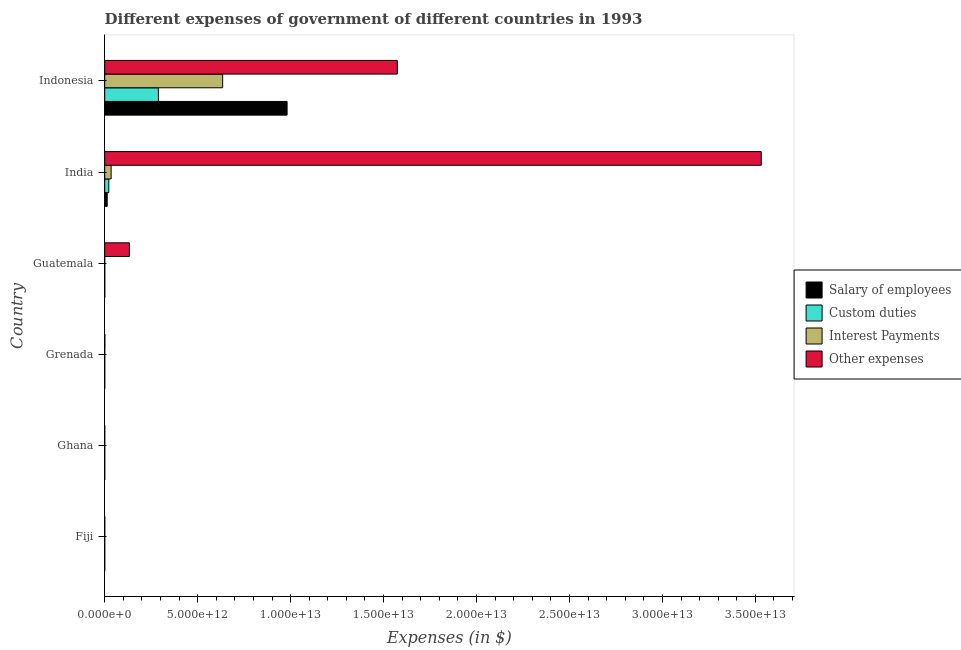How many bars are there on the 2nd tick from the top?
Keep it short and to the point. 4. What is the label of the 2nd group of bars from the top?
Give a very brief answer. India. What is the amount spent on interest payments in India?
Ensure brevity in your answer.  3.45e+11. Across all countries, what is the maximum amount spent on other expenses?
Give a very brief answer. 3.53e+13. Across all countries, what is the minimum amount spent on other expenses?
Keep it short and to the point. 1.56e+08. What is the total amount spent on salary of employees in the graph?
Your response must be concise. 9.95e+12. What is the difference between the amount spent on custom duties in Fiji and that in Guatemala?
Make the answer very short. -8.03e+08. What is the difference between the amount spent on salary of employees in Ghana and the amount spent on interest payments in India?
Your answer should be compact. -3.45e+11. What is the average amount spent on interest payments per country?
Ensure brevity in your answer.  1.11e+12. What is the difference between the amount spent on custom duties and amount spent on other expenses in Fiji?
Keep it short and to the point. -3.64e+08. Is the amount spent on interest payments in Ghana less than that in Grenada?
Ensure brevity in your answer.  Yes. Is the difference between the amount spent on other expenses in Fiji and Ghana greater than the difference between the amount spent on custom duties in Fiji and Ghana?
Ensure brevity in your answer.  Yes. What is the difference between the highest and the second highest amount spent on salary of employees?
Your response must be concise. 9.68e+12. What is the difference between the highest and the lowest amount spent on interest payments?
Make the answer very short. 6.34e+12. In how many countries, is the amount spent on other expenses greater than the average amount spent on other expenses taken over all countries?
Give a very brief answer. 2. Is the sum of the amount spent on other expenses in India and Indonesia greater than the maximum amount spent on salary of employees across all countries?
Give a very brief answer. Yes. Is it the case that in every country, the sum of the amount spent on salary of employees and amount spent on custom duties is greater than the sum of amount spent on interest payments and amount spent on other expenses?
Offer a very short reply. No. What does the 4th bar from the top in India represents?
Ensure brevity in your answer.  Salary of employees. What does the 1st bar from the bottom in Ghana represents?
Offer a terse response. Salary of employees. What is the difference between two consecutive major ticks on the X-axis?
Make the answer very short. 5.00e+12. Does the graph contain any zero values?
Provide a short and direct response. No. Does the graph contain grids?
Your answer should be very brief. No. How many legend labels are there?
Give a very brief answer. 4. How are the legend labels stacked?
Your response must be concise. Vertical. What is the title of the graph?
Your answer should be compact. Different expenses of government of different countries in 1993. What is the label or title of the X-axis?
Your answer should be very brief. Expenses (in $). What is the Expenses (in $) of Salary of employees in Fiji?
Give a very brief answer. 3.17e+08. What is the Expenses (in $) of Custom duties in Fiji?
Your response must be concise. 3.31e+08. What is the Expenses (in $) in Interest Payments in Fiji?
Your answer should be compact. 7.14e+07. What is the Expenses (in $) in Other expenses in Fiji?
Give a very brief answer. 6.96e+08. What is the Expenses (in $) of Salary of employees in Ghana?
Offer a very short reply. 2.28e+07. What is the Expenses (in $) in Custom duties in Ghana?
Your answer should be very brief. 1.33e+07. What is the Expenses (in $) of Interest Payments in Ghana?
Keep it short and to the point. 1.35e+07. What is the Expenses (in $) of Other expenses in Ghana?
Your response must be concise. 1.56e+08. What is the Expenses (in $) of Salary of employees in Grenada?
Ensure brevity in your answer.  1.02e+08. What is the Expenses (in $) of Custom duties in Grenada?
Provide a short and direct response. 3.00e+07. What is the Expenses (in $) of Interest Payments in Grenada?
Make the answer very short. 1.41e+07. What is the Expenses (in $) in Other expenses in Grenada?
Keep it short and to the point. 5.54e+09. What is the Expenses (in $) in Salary of employees in Guatemala?
Provide a succinct answer. 2.27e+09. What is the Expenses (in $) in Custom duties in Guatemala?
Your response must be concise. 1.13e+09. What is the Expenses (in $) of Interest Payments in Guatemala?
Make the answer very short. 5.79e+08. What is the Expenses (in $) in Other expenses in Guatemala?
Provide a short and direct response. 1.33e+12. What is the Expenses (in $) of Salary of employees in India?
Give a very brief answer. 1.34e+11. What is the Expenses (in $) in Custom duties in India?
Make the answer very short. 2.19e+11. What is the Expenses (in $) in Interest Payments in India?
Provide a short and direct response. 3.45e+11. What is the Expenses (in $) of Other expenses in India?
Offer a terse response. 3.53e+13. What is the Expenses (in $) in Salary of employees in Indonesia?
Ensure brevity in your answer.  9.81e+12. What is the Expenses (in $) in Custom duties in Indonesia?
Ensure brevity in your answer.  2.89e+12. What is the Expenses (in $) in Interest Payments in Indonesia?
Give a very brief answer. 6.34e+12. What is the Expenses (in $) in Other expenses in Indonesia?
Give a very brief answer. 1.57e+13. Across all countries, what is the maximum Expenses (in $) of Salary of employees?
Make the answer very short. 9.81e+12. Across all countries, what is the maximum Expenses (in $) of Custom duties?
Make the answer very short. 2.89e+12. Across all countries, what is the maximum Expenses (in $) in Interest Payments?
Provide a short and direct response. 6.34e+12. Across all countries, what is the maximum Expenses (in $) of Other expenses?
Ensure brevity in your answer.  3.53e+13. Across all countries, what is the minimum Expenses (in $) in Salary of employees?
Ensure brevity in your answer.  2.28e+07. Across all countries, what is the minimum Expenses (in $) in Custom duties?
Provide a succinct answer. 1.33e+07. Across all countries, what is the minimum Expenses (in $) of Interest Payments?
Provide a succinct answer. 1.35e+07. Across all countries, what is the minimum Expenses (in $) of Other expenses?
Offer a very short reply. 1.56e+08. What is the total Expenses (in $) of Salary of employees in the graph?
Give a very brief answer. 9.95e+12. What is the total Expenses (in $) of Custom duties in the graph?
Your response must be concise. 3.11e+12. What is the total Expenses (in $) of Interest Payments in the graph?
Make the answer very short. 6.69e+12. What is the total Expenses (in $) of Other expenses in the graph?
Provide a succinct answer. 5.24e+13. What is the difference between the Expenses (in $) of Salary of employees in Fiji and that in Ghana?
Your answer should be very brief. 2.94e+08. What is the difference between the Expenses (in $) in Custom duties in Fiji and that in Ghana?
Your answer should be compact. 3.18e+08. What is the difference between the Expenses (in $) of Interest Payments in Fiji and that in Ghana?
Make the answer very short. 5.79e+07. What is the difference between the Expenses (in $) of Other expenses in Fiji and that in Ghana?
Give a very brief answer. 5.40e+08. What is the difference between the Expenses (in $) of Salary of employees in Fiji and that in Grenada?
Offer a terse response. 2.15e+08. What is the difference between the Expenses (in $) in Custom duties in Fiji and that in Grenada?
Offer a terse response. 3.01e+08. What is the difference between the Expenses (in $) of Interest Payments in Fiji and that in Grenada?
Your response must be concise. 5.72e+07. What is the difference between the Expenses (in $) of Other expenses in Fiji and that in Grenada?
Your answer should be compact. -4.85e+09. What is the difference between the Expenses (in $) of Salary of employees in Fiji and that in Guatemala?
Offer a very short reply. -1.95e+09. What is the difference between the Expenses (in $) of Custom duties in Fiji and that in Guatemala?
Ensure brevity in your answer.  -8.03e+08. What is the difference between the Expenses (in $) in Interest Payments in Fiji and that in Guatemala?
Your answer should be very brief. -5.07e+08. What is the difference between the Expenses (in $) of Other expenses in Fiji and that in Guatemala?
Offer a terse response. -1.33e+12. What is the difference between the Expenses (in $) of Salary of employees in Fiji and that in India?
Your response must be concise. -1.33e+11. What is the difference between the Expenses (in $) of Custom duties in Fiji and that in India?
Offer a terse response. -2.19e+11. What is the difference between the Expenses (in $) in Interest Payments in Fiji and that in India?
Your response must be concise. -3.45e+11. What is the difference between the Expenses (in $) in Other expenses in Fiji and that in India?
Provide a succinct answer. -3.53e+13. What is the difference between the Expenses (in $) in Salary of employees in Fiji and that in Indonesia?
Ensure brevity in your answer.  -9.81e+12. What is the difference between the Expenses (in $) of Custom duties in Fiji and that in Indonesia?
Your answer should be very brief. -2.89e+12. What is the difference between the Expenses (in $) of Interest Payments in Fiji and that in Indonesia?
Provide a succinct answer. -6.34e+12. What is the difference between the Expenses (in $) in Other expenses in Fiji and that in Indonesia?
Your answer should be very brief. -1.57e+13. What is the difference between the Expenses (in $) of Salary of employees in Ghana and that in Grenada?
Provide a succinct answer. -7.96e+07. What is the difference between the Expenses (in $) of Custom duties in Ghana and that in Grenada?
Offer a terse response. -1.67e+07. What is the difference between the Expenses (in $) of Interest Payments in Ghana and that in Grenada?
Your response must be concise. -6.22e+05. What is the difference between the Expenses (in $) of Other expenses in Ghana and that in Grenada?
Ensure brevity in your answer.  -5.39e+09. What is the difference between the Expenses (in $) in Salary of employees in Ghana and that in Guatemala?
Provide a succinct answer. -2.25e+09. What is the difference between the Expenses (in $) of Custom duties in Ghana and that in Guatemala?
Ensure brevity in your answer.  -1.12e+09. What is the difference between the Expenses (in $) of Interest Payments in Ghana and that in Guatemala?
Provide a succinct answer. -5.65e+08. What is the difference between the Expenses (in $) of Other expenses in Ghana and that in Guatemala?
Give a very brief answer. -1.33e+12. What is the difference between the Expenses (in $) in Salary of employees in Ghana and that in India?
Offer a very short reply. -1.34e+11. What is the difference between the Expenses (in $) in Custom duties in Ghana and that in India?
Give a very brief answer. -2.19e+11. What is the difference between the Expenses (in $) of Interest Payments in Ghana and that in India?
Offer a very short reply. -3.45e+11. What is the difference between the Expenses (in $) of Other expenses in Ghana and that in India?
Ensure brevity in your answer.  -3.53e+13. What is the difference between the Expenses (in $) in Salary of employees in Ghana and that in Indonesia?
Make the answer very short. -9.81e+12. What is the difference between the Expenses (in $) in Custom duties in Ghana and that in Indonesia?
Offer a terse response. -2.89e+12. What is the difference between the Expenses (in $) in Interest Payments in Ghana and that in Indonesia?
Keep it short and to the point. -6.34e+12. What is the difference between the Expenses (in $) of Other expenses in Ghana and that in Indonesia?
Offer a terse response. -1.57e+13. What is the difference between the Expenses (in $) in Salary of employees in Grenada and that in Guatemala?
Make the answer very short. -2.17e+09. What is the difference between the Expenses (in $) of Custom duties in Grenada and that in Guatemala?
Provide a short and direct response. -1.10e+09. What is the difference between the Expenses (in $) of Interest Payments in Grenada and that in Guatemala?
Your answer should be very brief. -5.65e+08. What is the difference between the Expenses (in $) in Other expenses in Grenada and that in Guatemala?
Provide a succinct answer. -1.32e+12. What is the difference between the Expenses (in $) of Salary of employees in Grenada and that in India?
Ensure brevity in your answer.  -1.33e+11. What is the difference between the Expenses (in $) in Custom duties in Grenada and that in India?
Keep it short and to the point. -2.19e+11. What is the difference between the Expenses (in $) of Interest Payments in Grenada and that in India?
Make the answer very short. -3.45e+11. What is the difference between the Expenses (in $) in Other expenses in Grenada and that in India?
Your response must be concise. -3.53e+13. What is the difference between the Expenses (in $) of Salary of employees in Grenada and that in Indonesia?
Make the answer very short. -9.81e+12. What is the difference between the Expenses (in $) of Custom duties in Grenada and that in Indonesia?
Ensure brevity in your answer.  -2.89e+12. What is the difference between the Expenses (in $) of Interest Payments in Grenada and that in Indonesia?
Ensure brevity in your answer.  -6.34e+12. What is the difference between the Expenses (in $) in Other expenses in Grenada and that in Indonesia?
Your answer should be compact. -1.57e+13. What is the difference between the Expenses (in $) of Salary of employees in Guatemala and that in India?
Your answer should be compact. -1.31e+11. What is the difference between the Expenses (in $) in Custom duties in Guatemala and that in India?
Your answer should be very brief. -2.18e+11. What is the difference between the Expenses (in $) in Interest Payments in Guatemala and that in India?
Keep it short and to the point. -3.44e+11. What is the difference between the Expenses (in $) in Other expenses in Guatemala and that in India?
Make the answer very short. -3.40e+13. What is the difference between the Expenses (in $) of Salary of employees in Guatemala and that in Indonesia?
Provide a short and direct response. -9.81e+12. What is the difference between the Expenses (in $) in Custom duties in Guatemala and that in Indonesia?
Offer a terse response. -2.89e+12. What is the difference between the Expenses (in $) of Interest Payments in Guatemala and that in Indonesia?
Your answer should be compact. -6.34e+12. What is the difference between the Expenses (in $) of Other expenses in Guatemala and that in Indonesia?
Your response must be concise. -1.44e+13. What is the difference between the Expenses (in $) of Salary of employees in India and that in Indonesia?
Your response must be concise. -9.68e+12. What is the difference between the Expenses (in $) in Custom duties in India and that in Indonesia?
Give a very brief answer. -2.67e+12. What is the difference between the Expenses (in $) in Interest Payments in India and that in Indonesia?
Your answer should be very brief. -6.00e+12. What is the difference between the Expenses (in $) in Other expenses in India and that in Indonesia?
Offer a very short reply. 1.96e+13. What is the difference between the Expenses (in $) in Salary of employees in Fiji and the Expenses (in $) in Custom duties in Ghana?
Give a very brief answer. 3.04e+08. What is the difference between the Expenses (in $) of Salary of employees in Fiji and the Expenses (in $) of Interest Payments in Ghana?
Your response must be concise. 3.04e+08. What is the difference between the Expenses (in $) of Salary of employees in Fiji and the Expenses (in $) of Other expenses in Ghana?
Provide a succinct answer. 1.62e+08. What is the difference between the Expenses (in $) of Custom duties in Fiji and the Expenses (in $) of Interest Payments in Ghana?
Make the answer very short. 3.18e+08. What is the difference between the Expenses (in $) in Custom duties in Fiji and the Expenses (in $) in Other expenses in Ghana?
Offer a very short reply. 1.76e+08. What is the difference between the Expenses (in $) of Interest Payments in Fiji and the Expenses (in $) of Other expenses in Ghana?
Your answer should be compact. -8.42e+07. What is the difference between the Expenses (in $) in Salary of employees in Fiji and the Expenses (in $) in Custom duties in Grenada?
Your answer should be very brief. 2.87e+08. What is the difference between the Expenses (in $) of Salary of employees in Fiji and the Expenses (in $) of Interest Payments in Grenada?
Your answer should be very brief. 3.03e+08. What is the difference between the Expenses (in $) in Salary of employees in Fiji and the Expenses (in $) in Other expenses in Grenada?
Make the answer very short. -5.22e+09. What is the difference between the Expenses (in $) in Custom duties in Fiji and the Expenses (in $) in Interest Payments in Grenada?
Offer a very short reply. 3.17e+08. What is the difference between the Expenses (in $) in Custom duties in Fiji and the Expenses (in $) in Other expenses in Grenada?
Your answer should be compact. -5.21e+09. What is the difference between the Expenses (in $) in Interest Payments in Fiji and the Expenses (in $) in Other expenses in Grenada?
Offer a very short reply. -5.47e+09. What is the difference between the Expenses (in $) of Salary of employees in Fiji and the Expenses (in $) of Custom duties in Guatemala?
Provide a short and direct response. -8.17e+08. What is the difference between the Expenses (in $) of Salary of employees in Fiji and the Expenses (in $) of Interest Payments in Guatemala?
Offer a terse response. -2.62e+08. What is the difference between the Expenses (in $) in Salary of employees in Fiji and the Expenses (in $) in Other expenses in Guatemala?
Keep it short and to the point. -1.33e+12. What is the difference between the Expenses (in $) in Custom duties in Fiji and the Expenses (in $) in Interest Payments in Guatemala?
Make the answer very short. -2.47e+08. What is the difference between the Expenses (in $) of Custom duties in Fiji and the Expenses (in $) of Other expenses in Guatemala?
Provide a succinct answer. -1.33e+12. What is the difference between the Expenses (in $) in Interest Payments in Fiji and the Expenses (in $) in Other expenses in Guatemala?
Make the answer very short. -1.33e+12. What is the difference between the Expenses (in $) of Salary of employees in Fiji and the Expenses (in $) of Custom duties in India?
Make the answer very short. -2.19e+11. What is the difference between the Expenses (in $) of Salary of employees in Fiji and the Expenses (in $) of Interest Payments in India?
Your answer should be compact. -3.45e+11. What is the difference between the Expenses (in $) of Salary of employees in Fiji and the Expenses (in $) of Other expenses in India?
Make the answer very short. -3.53e+13. What is the difference between the Expenses (in $) in Custom duties in Fiji and the Expenses (in $) in Interest Payments in India?
Your response must be concise. -3.45e+11. What is the difference between the Expenses (in $) in Custom duties in Fiji and the Expenses (in $) in Other expenses in India?
Ensure brevity in your answer.  -3.53e+13. What is the difference between the Expenses (in $) of Interest Payments in Fiji and the Expenses (in $) of Other expenses in India?
Give a very brief answer. -3.53e+13. What is the difference between the Expenses (in $) of Salary of employees in Fiji and the Expenses (in $) of Custom duties in Indonesia?
Give a very brief answer. -2.89e+12. What is the difference between the Expenses (in $) of Salary of employees in Fiji and the Expenses (in $) of Interest Payments in Indonesia?
Provide a short and direct response. -6.34e+12. What is the difference between the Expenses (in $) of Salary of employees in Fiji and the Expenses (in $) of Other expenses in Indonesia?
Provide a short and direct response. -1.57e+13. What is the difference between the Expenses (in $) of Custom duties in Fiji and the Expenses (in $) of Interest Payments in Indonesia?
Your answer should be very brief. -6.34e+12. What is the difference between the Expenses (in $) in Custom duties in Fiji and the Expenses (in $) in Other expenses in Indonesia?
Offer a terse response. -1.57e+13. What is the difference between the Expenses (in $) in Interest Payments in Fiji and the Expenses (in $) in Other expenses in Indonesia?
Provide a succinct answer. -1.57e+13. What is the difference between the Expenses (in $) of Salary of employees in Ghana and the Expenses (in $) of Custom duties in Grenada?
Your answer should be very brief. -7.21e+06. What is the difference between the Expenses (in $) in Salary of employees in Ghana and the Expenses (in $) in Interest Payments in Grenada?
Your answer should be compact. 8.66e+06. What is the difference between the Expenses (in $) in Salary of employees in Ghana and the Expenses (in $) in Other expenses in Grenada?
Your answer should be very brief. -5.52e+09. What is the difference between the Expenses (in $) of Custom duties in Ghana and the Expenses (in $) of Interest Payments in Grenada?
Your answer should be compact. -8.35e+05. What is the difference between the Expenses (in $) in Custom duties in Ghana and the Expenses (in $) in Other expenses in Grenada?
Your response must be concise. -5.53e+09. What is the difference between the Expenses (in $) of Interest Payments in Ghana and the Expenses (in $) of Other expenses in Grenada?
Keep it short and to the point. -5.53e+09. What is the difference between the Expenses (in $) of Salary of employees in Ghana and the Expenses (in $) of Custom duties in Guatemala?
Your response must be concise. -1.11e+09. What is the difference between the Expenses (in $) in Salary of employees in Ghana and the Expenses (in $) in Interest Payments in Guatemala?
Your answer should be very brief. -5.56e+08. What is the difference between the Expenses (in $) of Salary of employees in Ghana and the Expenses (in $) of Other expenses in Guatemala?
Your answer should be very brief. -1.33e+12. What is the difference between the Expenses (in $) of Custom duties in Ghana and the Expenses (in $) of Interest Payments in Guatemala?
Give a very brief answer. -5.66e+08. What is the difference between the Expenses (in $) in Custom duties in Ghana and the Expenses (in $) in Other expenses in Guatemala?
Provide a succinct answer. -1.33e+12. What is the difference between the Expenses (in $) in Interest Payments in Ghana and the Expenses (in $) in Other expenses in Guatemala?
Ensure brevity in your answer.  -1.33e+12. What is the difference between the Expenses (in $) in Salary of employees in Ghana and the Expenses (in $) in Custom duties in India?
Your response must be concise. -2.19e+11. What is the difference between the Expenses (in $) of Salary of employees in Ghana and the Expenses (in $) of Interest Payments in India?
Your answer should be compact. -3.45e+11. What is the difference between the Expenses (in $) of Salary of employees in Ghana and the Expenses (in $) of Other expenses in India?
Offer a terse response. -3.53e+13. What is the difference between the Expenses (in $) of Custom duties in Ghana and the Expenses (in $) of Interest Payments in India?
Your answer should be very brief. -3.45e+11. What is the difference between the Expenses (in $) in Custom duties in Ghana and the Expenses (in $) in Other expenses in India?
Give a very brief answer. -3.53e+13. What is the difference between the Expenses (in $) in Interest Payments in Ghana and the Expenses (in $) in Other expenses in India?
Your response must be concise. -3.53e+13. What is the difference between the Expenses (in $) of Salary of employees in Ghana and the Expenses (in $) of Custom duties in Indonesia?
Keep it short and to the point. -2.89e+12. What is the difference between the Expenses (in $) of Salary of employees in Ghana and the Expenses (in $) of Interest Payments in Indonesia?
Make the answer very short. -6.34e+12. What is the difference between the Expenses (in $) in Salary of employees in Ghana and the Expenses (in $) in Other expenses in Indonesia?
Give a very brief answer. -1.57e+13. What is the difference between the Expenses (in $) of Custom duties in Ghana and the Expenses (in $) of Interest Payments in Indonesia?
Provide a succinct answer. -6.34e+12. What is the difference between the Expenses (in $) of Custom duties in Ghana and the Expenses (in $) of Other expenses in Indonesia?
Provide a short and direct response. -1.57e+13. What is the difference between the Expenses (in $) in Interest Payments in Ghana and the Expenses (in $) in Other expenses in Indonesia?
Ensure brevity in your answer.  -1.57e+13. What is the difference between the Expenses (in $) of Salary of employees in Grenada and the Expenses (in $) of Custom duties in Guatemala?
Ensure brevity in your answer.  -1.03e+09. What is the difference between the Expenses (in $) in Salary of employees in Grenada and the Expenses (in $) in Interest Payments in Guatemala?
Offer a very short reply. -4.76e+08. What is the difference between the Expenses (in $) of Salary of employees in Grenada and the Expenses (in $) of Other expenses in Guatemala?
Provide a succinct answer. -1.33e+12. What is the difference between the Expenses (in $) of Custom duties in Grenada and the Expenses (in $) of Interest Payments in Guatemala?
Your response must be concise. -5.49e+08. What is the difference between the Expenses (in $) in Custom duties in Grenada and the Expenses (in $) in Other expenses in Guatemala?
Your answer should be compact. -1.33e+12. What is the difference between the Expenses (in $) of Interest Payments in Grenada and the Expenses (in $) of Other expenses in Guatemala?
Offer a very short reply. -1.33e+12. What is the difference between the Expenses (in $) in Salary of employees in Grenada and the Expenses (in $) in Custom duties in India?
Offer a very short reply. -2.19e+11. What is the difference between the Expenses (in $) in Salary of employees in Grenada and the Expenses (in $) in Interest Payments in India?
Give a very brief answer. -3.45e+11. What is the difference between the Expenses (in $) in Salary of employees in Grenada and the Expenses (in $) in Other expenses in India?
Your answer should be compact. -3.53e+13. What is the difference between the Expenses (in $) of Custom duties in Grenada and the Expenses (in $) of Interest Payments in India?
Provide a short and direct response. -3.45e+11. What is the difference between the Expenses (in $) in Custom duties in Grenada and the Expenses (in $) in Other expenses in India?
Offer a very short reply. -3.53e+13. What is the difference between the Expenses (in $) in Interest Payments in Grenada and the Expenses (in $) in Other expenses in India?
Provide a short and direct response. -3.53e+13. What is the difference between the Expenses (in $) in Salary of employees in Grenada and the Expenses (in $) in Custom duties in Indonesia?
Ensure brevity in your answer.  -2.89e+12. What is the difference between the Expenses (in $) in Salary of employees in Grenada and the Expenses (in $) in Interest Payments in Indonesia?
Ensure brevity in your answer.  -6.34e+12. What is the difference between the Expenses (in $) of Salary of employees in Grenada and the Expenses (in $) of Other expenses in Indonesia?
Offer a terse response. -1.57e+13. What is the difference between the Expenses (in $) in Custom duties in Grenada and the Expenses (in $) in Interest Payments in Indonesia?
Provide a succinct answer. -6.34e+12. What is the difference between the Expenses (in $) in Custom duties in Grenada and the Expenses (in $) in Other expenses in Indonesia?
Offer a terse response. -1.57e+13. What is the difference between the Expenses (in $) in Interest Payments in Grenada and the Expenses (in $) in Other expenses in Indonesia?
Provide a succinct answer. -1.57e+13. What is the difference between the Expenses (in $) of Salary of employees in Guatemala and the Expenses (in $) of Custom duties in India?
Your answer should be very brief. -2.17e+11. What is the difference between the Expenses (in $) in Salary of employees in Guatemala and the Expenses (in $) in Interest Payments in India?
Your response must be concise. -3.43e+11. What is the difference between the Expenses (in $) in Salary of employees in Guatemala and the Expenses (in $) in Other expenses in India?
Your response must be concise. -3.53e+13. What is the difference between the Expenses (in $) of Custom duties in Guatemala and the Expenses (in $) of Interest Payments in India?
Your answer should be compact. -3.44e+11. What is the difference between the Expenses (in $) in Custom duties in Guatemala and the Expenses (in $) in Other expenses in India?
Your response must be concise. -3.53e+13. What is the difference between the Expenses (in $) of Interest Payments in Guatemala and the Expenses (in $) of Other expenses in India?
Give a very brief answer. -3.53e+13. What is the difference between the Expenses (in $) of Salary of employees in Guatemala and the Expenses (in $) of Custom duties in Indonesia?
Keep it short and to the point. -2.89e+12. What is the difference between the Expenses (in $) in Salary of employees in Guatemala and the Expenses (in $) in Interest Payments in Indonesia?
Your answer should be compact. -6.34e+12. What is the difference between the Expenses (in $) in Salary of employees in Guatemala and the Expenses (in $) in Other expenses in Indonesia?
Offer a terse response. -1.57e+13. What is the difference between the Expenses (in $) of Custom duties in Guatemala and the Expenses (in $) of Interest Payments in Indonesia?
Provide a short and direct response. -6.34e+12. What is the difference between the Expenses (in $) of Custom duties in Guatemala and the Expenses (in $) of Other expenses in Indonesia?
Your answer should be compact. -1.57e+13. What is the difference between the Expenses (in $) of Interest Payments in Guatemala and the Expenses (in $) of Other expenses in Indonesia?
Your response must be concise. -1.57e+13. What is the difference between the Expenses (in $) of Salary of employees in India and the Expenses (in $) of Custom duties in Indonesia?
Give a very brief answer. -2.75e+12. What is the difference between the Expenses (in $) of Salary of employees in India and the Expenses (in $) of Interest Payments in Indonesia?
Your answer should be compact. -6.21e+12. What is the difference between the Expenses (in $) of Salary of employees in India and the Expenses (in $) of Other expenses in Indonesia?
Your answer should be very brief. -1.56e+13. What is the difference between the Expenses (in $) of Custom duties in India and the Expenses (in $) of Interest Payments in Indonesia?
Offer a terse response. -6.12e+12. What is the difference between the Expenses (in $) in Custom duties in India and the Expenses (in $) in Other expenses in Indonesia?
Keep it short and to the point. -1.55e+13. What is the difference between the Expenses (in $) in Interest Payments in India and the Expenses (in $) in Other expenses in Indonesia?
Your answer should be very brief. -1.54e+13. What is the average Expenses (in $) in Salary of employees per country?
Provide a succinct answer. 1.66e+12. What is the average Expenses (in $) in Custom duties per country?
Give a very brief answer. 5.18e+11. What is the average Expenses (in $) in Interest Payments per country?
Provide a short and direct response. 1.11e+12. What is the average Expenses (in $) of Other expenses per country?
Provide a short and direct response. 8.73e+12. What is the difference between the Expenses (in $) in Salary of employees and Expenses (in $) in Custom duties in Fiji?
Your answer should be very brief. -1.42e+07. What is the difference between the Expenses (in $) in Salary of employees and Expenses (in $) in Interest Payments in Fiji?
Ensure brevity in your answer.  2.46e+08. What is the difference between the Expenses (in $) of Salary of employees and Expenses (in $) of Other expenses in Fiji?
Your response must be concise. -3.78e+08. What is the difference between the Expenses (in $) in Custom duties and Expenses (in $) in Interest Payments in Fiji?
Your answer should be very brief. 2.60e+08. What is the difference between the Expenses (in $) in Custom duties and Expenses (in $) in Other expenses in Fiji?
Make the answer very short. -3.64e+08. What is the difference between the Expenses (in $) in Interest Payments and Expenses (in $) in Other expenses in Fiji?
Offer a very short reply. -6.24e+08. What is the difference between the Expenses (in $) of Salary of employees and Expenses (in $) of Custom duties in Ghana?
Keep it short and to the point. 9.49e+06. What is the difference between the Expenses (in $) in Salary of employees and Expenses (in $) in Interest Payments in Ghana?
Provide a succinct answer. 9.28e+06. What is the difference between the Expenses (in $) of Salary of employees and Expenses (in $) of Other expenses in Ghana?
Your response must be concise. -1.33e+08. What is the difference between the Expenses (in $) in Custom duties and Expenses (in $) in Interest Payments in Ghana?
Provide a succinct answer. -2.12e+05. What is the difference between the Expenses (in $) of Custom duties and Expenses (in $) of Other expenses in Ghana?
Your answer should be very brief. -1.42e+08. What is the difference between the Expenses (in $) in Interest Payments and Expenses (in $) in Other expenses in Ghana?
Ensure brevity in your answer.  -1.42e+08. What is the difference between the Expenses (in $) in Salary of employees and Expenses (in $) in Custom duties in Grenada?
Offer a very short reply. 7.24e+07. What is the difference between the Expenses (in $) in Salary of employees and Expenses (in $) in Interest Payments in Grenada?
Make the answer very short. 8.82e+07. What is the difference between the Expenses (in $) in Salary of employees and Expenses (in $) in Other expenses in Grenada?
Your response must be concise. -5.44e+09. What is the difference between the Expenses (in $) of Custom duties and Expenses (in $) of Interest Payments in Grenada?
Provide a short and direct response. 1.59e+07. What is the difference between the Expenses (in $) of Custom duties and Expenses (in $) of Other expenses in Grenada?
Your answer should be very brief. -5.51e+09. What is the difference between the Expenses (in $) of Interest Payments and Expenses (in $) of Other expenses in Grenada?
Offer a very short reply. -5.53e+09. What is the difference between the Expenses (in $) in Salary of employees and Expenses (in $) in Custom duties in Guatemala?
Offer a very short reply. 1.14e+09. What is the difference between the Expenses (in $) of Salary of employees and Expenses (in $) of Interest Payments in Guatemala?
Ensure brevity in your answer.  1.69e+09. What is the difference between the Expenses (in $) of Salary of employees and Expenses (in $) of Other expenses in Guatemala?
Make the answer very short. -1.32e+12. What is the difference between the Expenses (in $) of Custom duties and Expenses (in $) of Interest Payments in Guatemala?
Keep it short and to the point. 5.55e+08. What is the difference between the Expenses (in $) of Custom duties and Expenses (in $) of Other expenses in Guatemala?
Offer a very short reply. -1.33e+12. What is the difference between the Expenses (in $) of Interest Payments and Expenses (in $) of Other expenses in Guatemala?
Your response must be concise. -1.33e+12. What is the difference between the Expenses (in $) in Salary of employees and Expenses (in $) in Custom duties in India?
Offer a terse response. -8.55e+1. What is the difference between the Expenses (in $) in Salary of employees and Expenses (in $) in Interest Payments in India?
Your answer should be compact. -2.11e+11. What is the difference between the Expenses (in $) in Salary of employees and Expenses (in $) in Other expenses in India?
Your answer should be compact. -3.52e+13. What is the difference between the Expenses (in $) of Custom duties and Expenses (in $) of Interest Payments in India?
Offer a very short reply. -1.26e+11. What is the difference between the Expenses (in $) of Custom duties and Expenses (in $) of Other expenses in India?
Your response must be concise. -3.51e+13. What is the difference between the Expenses (in $) of Interest Payments and Expenses (in $) of Other expenses in India?
Make the answer very short. -3.50e+13. What is the difference between the Expenses (in $) of Salary of employees and Expenses (in $) of Custom duties in Indonesia?
Your answer should be compact. 6.92e+12. What is the difference between the Expenses (in $) in Salary of employees and Expenses (in $) in Interest Payments in Indonesia?
Offer a very short reply. 3.47e+12. What is the difference between the Expenses (in $) of Salary of employees and Expenses (in $) of Other expenses in Indonesia?
Your response must be concise. -5.93e+12. What is the difference between the Expenses (in $) of Custom duties and Expenses (in $) of Interest Payments in Indonesia?
Provide a succinct answer. -3.46e+12. What is the difference between the Expenses (in $) of Custom duties and Expenses (in $) of Other expenses in Indonesia?
Give a very brief answer. -1.29e+13. What is the difference between the Expenses (in $) in Interest Payments and Expenses (in $) in Other expenses in Indonesia?
Provide a succinct answer. -9.40e+12. What is the ratio of the Expenses (in $) in Salary of employees in Fiji to that in Ghana?
Provide a succinct answer. 13.94. What is the ratio of the Expenses (in $) of Custom duties in Fiji to that in Ghana?
Provide a short and direct response. 24.98. What is the ratio of the Expenses (in $) in Interest Payments in Fiji to that in Ghana?
Offer a very short reply. 5.29. What is the ratio of the Expenses (in $) in Other expenses in Fiji to that in Ghana?
Your answer should be compact. 4.47. What is the ratio of the Expenses (in $) of Salary of employees in Fiji to that in Grenada?
Your answer should be very brief. 3.1. What is the ratio of the Expenses (in $) in Custom duties in Fiji to that in Grenada?
Offer a very short reply. 11.06. What is the ratio of the Expenses (in $) of Interest Payments in Fiji to that in Grenada?
Give a very brief answer. 5.06. What is the ratio of the Expenses (in $) in Other expenses in Fiji to that in Grenada?
Offer a very short reply. 0.13. What is the ratio of the Expenses (in $) in Salary of employees in Fiji to that in Guatemala?
Offer a terse response. 0.14. What is the ratio of the Expenses (in $) in Custom duties in Fiji to that in Guatemala?
Your answer should be compact. 0.29. What is the ratio of the Expenses (in $) of Interest Payments in Fiji to that in Guatemala?
Give a very brief answer. 0.12. What is the ratio of the Expenses (in $) in Other expenses in Fiji to that in Guatemala?
Your answer should be compact. 0. What is the ratio of the Expenses (in $) of Salary of employees in Fiji to that in India?
Make the answer very short. 0. What is the ratio of the Expenses (in $) in Custom duties in Fiji to that in India?
Your response must be concise. 0. What is the ratio of the Expenses (in $) in Salary of employees in Fiji to that in Indonesia?
Your response must be concise. 0. What is the ratio of the Expenses (in $) of Salary of employees in Ghana to that in Grenada?
Your response must be concise. 0.22. What is the ratio of the Expenses (in $) in Custom duties in Ghana to that in Grenada?
Keep it short and to the point. 0.44. What is the ratio of the Expenses (in $) of Interest Payments in Ghana to that in Grenada?
Your response must be concise. 0.96. What is the ratio of the Expenses (in $) of Other expenses in Ghana to that in Grenada?
Make the answer very short. 0.03. What is the ratio of the Expenses (in $) of Salary of employees in Ghana to that in Guatemala?
Offer a very short reply. 0.01. What is the ratio of the Expenses (in $) of Custom duties in Ghana to that in Guatemala?
Ensure brevity in your answer.  0.01. What is the ratio of the Expenses (in $) in Interest Payments in Ghana to that in Guatemala?
Provide a short and direct response. 0.02. What is the ratio of the Expenses (in $) of Other expenses in Ghana to that in Guatemala?
Provide a short and direct response. 0. What is the ratio of the Expenses (in $) of Custom duties in Ghana to that in Indonesia?
Provide a short and direct response. 0. What is the ratio of the Expenses (in $) in Salary of employees in Grenada to that in Guatemala?
Offer a very short reply. 0.05. What is the ratio of the Expenses (in $) in Custom duties in Grenada to that in Guatemala?
Your response must be concise. 0.03. What is the ratio of the Expenses (in $) in Interest Payments in Grenada to that in Guatemala?
Offer a very short reply. 0.02. What is the ratio of the Expenses (in $) in Other expenses in Grenada to that in Guatemala?
Your answer should be very brief. 0. What is the ratio of the Expenses (in $) in Salary of employees in Grenada to that in India?
Offer a very short reply. 0. What is the ratio of the Expenses (in $) in Custom duties in Grenada to that in Indonesia?
Your answer should be compact. 0. What is the ratio of the Expenses (in $) in Other expenses in Grenada to that in Indonesia?
Ensure brevity in your answer.  0. What is the ratio of the Expenses (in $) of Salary of employees in Guatemala to that in India?
Provide a succinct answer. 0.02. What is the ratio of the Expenses (in $) of Custom duties in Guatemala to that in India?
Give a very brief answer. 0.01. What is the ratio of the Expenses (in $) of Interest Payments in Guatemala to that in India?
Your answer should be very brief. 0. What is the ratio of the Expenses (in $) of Other expenses in Guatemala to that in India?
Your response must be concise. 0.04. What is the ratio of the Expenses (in $) of Interest Payments in Guatemala to that in Indonesia?
Your answer should be very brief. 0. What is the ratio of the Expenses (in $) in Other expenses in Guatemala to that in Indonesia?
Your answer should be compact. 0.08. What is the ratio of the Expenses (in $) of Salary of employees in India to that in Indonesia?
Provide a succinct answer. 0.01. What is the ratio of the Expenses (in $) in Custom duties in India to that in Indonesia?
Give a very brief answer. 0.08. What is the ratio of the Expenses (in $) of Interest Payments in India to that in Indonesia?
Keep it short and to the point. 0.05. What is the ratio of the Expenses (in $) in Other expenses in India to that in Indonesia?
Your answer should be very brief. 2.24. What is the difference between the highest and the second highest Expenses (in $) of Salary of employees?
Give a very brief answer. 9.68e+12. What is the difference between the highest and the second highest Expenses (in $) in Custom duties?
Your response must be concise. 2.67e+12. What is the difference between the highest and the second highest Expenses (in $) of Interest Payments?
Ensure brevity in your answer.  6.00e+12. What is the difference between the highest and the second highest Expenses (in $) of Other expenses?
Your response must be concise. 1.96e+13. What is the difference between the highest and the lowest Expenses (in $) in Salary of employees?
Offer a terse response. 9.81e+12. What is the difference between the highest and the lowest Expenses (in $) in Custom duties?
Keep it short and to the point. 2.89e+12. What is the difference between the highest and the lowest Expenses (in $) in Interest Payments?
Your answer should be very brief. 6.34e+12. What is the difference between the highest and the lowest Expenses (in $) of Other expenses?
Your response must be concise. 3.53e+13. 